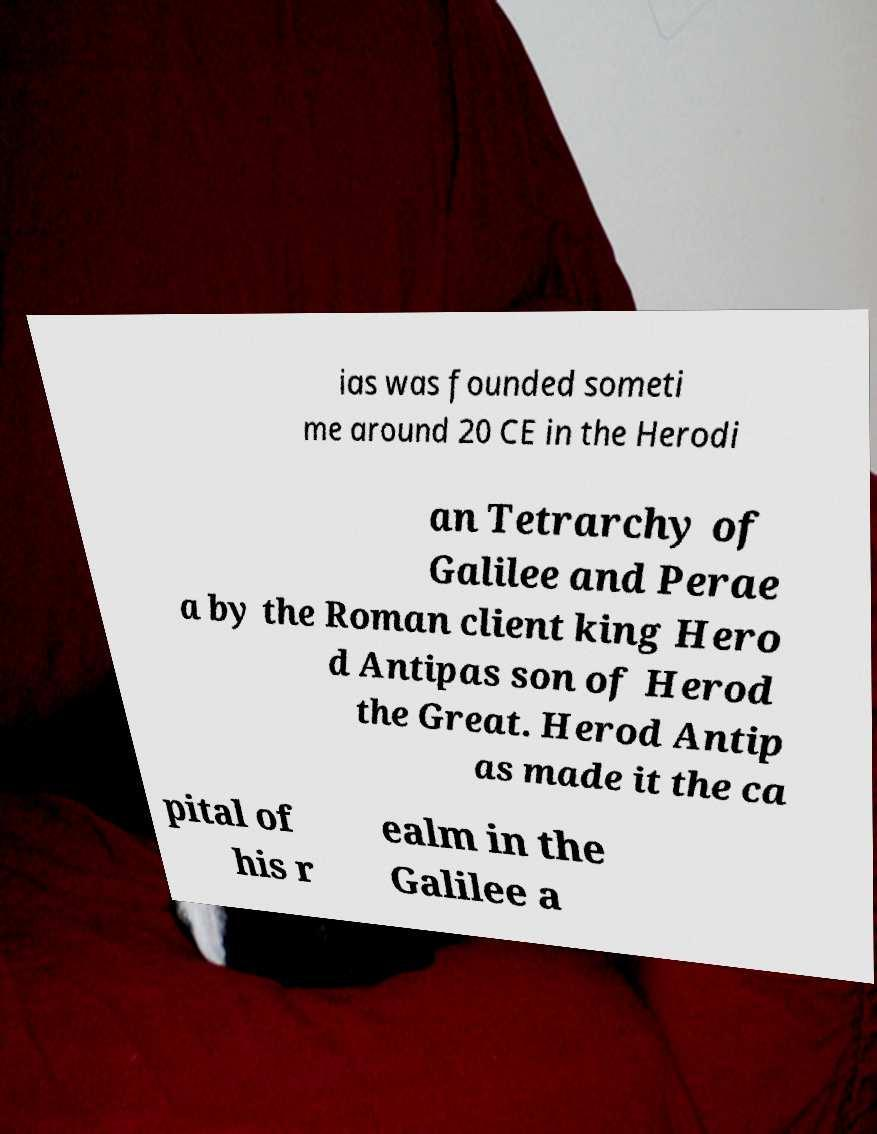Can you read and provide the text displayed in the image?This photo seems to have some interesting text. Can you extract and type it out for me? ias was founded someti me around 20 CE in the Herodi an Tetrarchy of Galilee and Perae a by the Roman client king Hero d Antipas son of Herod the Great. Herod Antip as made it the ca pital of his r ealm in the Galilee a 